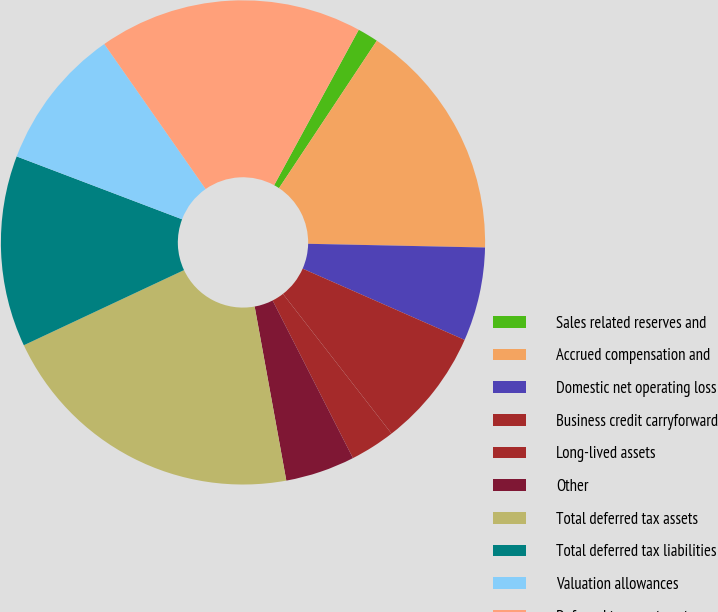Convert chart. <chart><loc_0><loc_0><loc_500><loc_500><pie_chart><fcel>Sales related reserves and<fcel>Accrued compensation and<fcel>Domestic net operating loss<fcel>Business credit carryforward<fcel>Long-lived assets<fcel>Other<fcel>Total deferred tax assets<fcel>Total deferred tax liabilities<fcel>Valuation allowances<fcel>Deferred tax assets net<nl><fcel>1.39%<fcel>16.01%<fcel>6.26%<fcel>7.89%<fcel>3.01%<fcel>4.64%<fcel>20.88%<fcel>12.76%<fcel>9.51%<fcel>17.64%<nl></chart> 